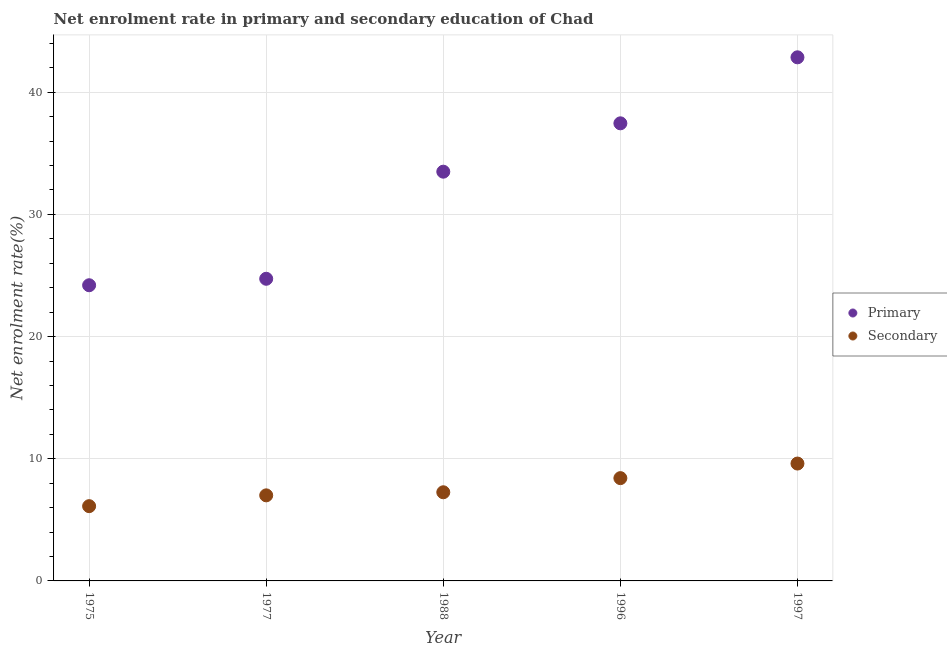How many different coloured dotlines are there?
Your answer should be compact. 2. What is the enrollment rate in primary education in 1988?
Provide a succinct answer. 33.5. Across all years, what is the maximum enrollment rate in primary education?
Keep it short and to the point. 42.86. Across all years, what is the minimum enrollment rate in primary education?
Your answer should be compact. 24.2. In which year was the enrollment rate in primary education maximum?
Provide a short and direct response. 1997. In which year was the enrollment rate in primary education minimum?
Offer a very short reply. 1975. What is the total enrollment rate in primary education in the graph?
Offer a terse response. 162.74. What is the difference between the enrollment rate in secondary education in 1975 and that in 1977?
Provide a succinct answer. -0.88. What is the difference between the enrollment rate in primary education in 1977 and the enrollment rate in secondary education in 1988?
Provide a short and direct response. 17.47. What is the average enrollment rate in secondary education per year?
Your answer should be very brief. 7.68. In the year 1996, what is the difference between the enrollment rate in primary education and enrollment rate in secondary education?
Make the answer very short. 29.04. What is the ratio of the enrollment rate in secondary education in 1975 to that in 1988?
Your answer should be compact. 0.84. Is the enrollment rate in primary education in 1975 less than that in 1997?
Provide a short and direct response. Yes. What is the difference between the highest and the second highest enrollment rate in primary education?
Give a very brief answer. 5.4. What is the difference between the highest and the lowest enrollment rate in primary education?
Your answer should be compact. 18.66. In how many years, is the enrollment rate in secondary education greater than the average enrollment rate in secondary education taken over all years?
Keep it short and to the point. 2. Is the sum of the enrollment rate in primary education in 1975 and 1996 greater than the maximum enrollment rate in secondary education across all years?
Keep it short and to the point. Yes. Does the enrollment rate in secondary education monotonically increase over the years?
Provide a succinct answer. Yes. Is the enrollment rate in secondary education strictly less than the enrollment rate in primary education over the years?
Provide a short and direct response. Yes. How many dotlines are there?
Offer a terse response. 2. How many legend labels are there?
Your answer should be compact. 2. What is the title of the graph?
Give a very brief answer. Net enrolment rate in primary and secondary education of Chad. Does "Mobile cellular" appear as one of the legend labels in the graph?
Make the answer very short. No. What is the label or title of the X-axis?
Your answer should be compact. Year. What is the label or title of the Y-axis?
Keep it short and to the point. Net enrolment rate(%). What is the Net enrolment rate(%) in Primary in 1975?
Keep it short and to the point. 24.2. What is the Net enrolment rate(%) in Secondary in 1975?
Your answer should be compact. 6.12. What is the Net enrolment rate(%) of Primary in 1977?
Give a very brief answer. 24.73. What is the Net enrolment rate(%) in Secondary in 1977?
Offer a very short reply. 7. What is the Net enrolment rate(%) of Primary in 1988?
Your answer should be very brief. 33.5. What is the Net enrolment rate(%) in Secondary in 1988?
Give a very brief answer. 7.26. What is the Net enrolment rate(%) of Primary in 1996?
Keep it short and to the point. 37.46. What is the Net enrolment rate(%) of Secondary in 1996?
Provide a succinct answer. 8.41. What is the Net enrolment rate(%) in Primary in 1997?
Your answer should be compact. 42.86. What is the Net enrolment rate(%) in Secondary in 1997?
Ensure brevity in your answer.  9.61. Across all years, what is the maximum Net enrolment rate(%) in Primary?
Your answer should be very brief. 42.86. Across all years, what is the maximum Net enrolment rate(%) of Secondary?
Your answer should be very brief. 9.61. Across all years, what is the minimum Net enrolment rate(%) in Primary?
Offer a very short reply. 24.2. Across all years, what is the minimum Net enrolment rate(%) of Secondary?
Offer a terse response. 6.12. What is the total Net enrolment rate(%) in Primary in the graph?
Give a very brief answer. 162.74. What is the total Net enrolment rate(%) of Secondary in the graph?
Make the answer very short. 38.4. What is the difference between the Net enrolment rate(%) of Primary in 1975 and that in 1977?
Keep it short and to the point. -0.53. What is the difference between the Net enrolment rate(%) of Secondary in 1975 and that in 1977?
Your answer should be compact. -0.88. What is the difference between the Net enrolment rate(%) of Primary in 1975 and that in 1988?
Your answer should be very brief. -9.3. What is the difference between the Net enrolment rate(%) of Secondary in 1975 and that in 1988?
Provide a succinct answer. -1.14. What is the difference between the Net enrolment rate(%) of Primary in 1975 and that in 1996?
Your answer should be very brief. -13.25. What is the difference between the Net enrolment rate(%) of Secondary in 1975 and that in 1996?
Ensure brevity in your answer.  -2.29. What is the difference between the Net enrolment rate(%) in Primary in 1975 and that in 1997?
Your answer should be compact. -18.66. What is the difference between the Net enrolment rate(%) of Secondary in 1975 and that in 1997?
Ensure brevity in your answer.  -3.49. What is the difference between the Net enrolment rate(%) in Primary in 1977 and that in 1988?
Offer a terse response. -8.77. What is the difference between the Net enrolment rate(%) of Secondary in 1977 and that in 1988?
Your response must be concise. -0.25. What is the difference between the Net enrolment rate(%) of Primary in 1977 and that in 1996?
Offer a terse response. -12.72. What is the difference between the Net enrolment rate(%) of Secondary in 1977 and that in 1996?
Your answer should be very brief. -1.41. What is the difference between the Net enrolment rate(%) in Primary in 1977 and that in 1997?
Offer a terse response. -18.13. What is the difference between the Net enrolment rate(%) of Secondary in 1977 and that in 1997?
Offer a very short reply. -2.6. What is the difference between the Net enrolment rate(%) of Primary in 1988 and that in 1996?
Ensure brevity in your answer.  -3.96. What is the difference between the Net enrolment rate(%) in Secondary in 1988 and that in 1996?
Ensure brevity in your answer.  -1.16. What is the difference between the Net enrolment rate(%) of Primary in 1988 and that in 1997?
Your response must be concise. -9.36. What is the difference between the Net enrolment rate(%) of Secondary in 1988 and that in 1997?
Your response must be concise. -2.35. What is the difference between the Net enrolment rate(%) in Primary in 1996 and that in 1997?
Your answer should be very brief. -5.4. What is the difference between the Net enrolment rate(%) of Secondary in 1996 and that in 1997?
Make the answer very short. -1.19. What is the difference between the Net enrolment rate(%) of Primary in 1975 and the Net enrolment rate(%) of Secondary in 1977?
Your answer should be very brief. 17.2. What is the difference between the Net enrolment rate(%) of Primary in 1975 and the Net enrolment rate(%) of Secondary in 1988?
Offer a terse response. 16.95. What is the difference between the Net enrolment rate(%) of Primary in 1975 and the Net enrolment rate(%) of Secondary in 1996?
Keep it short and to the point. 15.79. What is the difference between the Net enrolment rate(%) of Primary in 1975 and the Net enrolment rate(%) of Secondary in 1997?
Offer a terse response. 14.59. What is the difference between the Net enrolment rate(%) of Primary in 1977 and the Net enrolment rate(%) of Secondary in 1988?
Ensure brevity in your answer.  17.47. What is the difference between the Net enrolment rate(%) in Primary in 1977 and the Net enrolment rate(%) in Secondary in 1996?
Give a very brief answer. 16.32. What is the difference between the Net enrolment rate(%) of Primary in 1977 and the Net enrolment rate(%) of Secondary in 1997?
Ensure brevity in your answer.  15.12. What is the difference between the Net enrolment rate(%) of Primary in 1988 and the Net enrolment rate(%) of Secondary in 1996?
Offer a terse response. 25.08. What is the difference between the Net enrolment rate(%) of Primary in 1988 and the Net enrolment rate(%) of Secondary in 1997?
Ensure brevity in your answer.  23.89. What is the difference between the Net enrolment rate(%) in Primary in 1996 and the Net enrolment rate(%) in Secondary in 1997?
Ensure brevity in your answer.  27.85. What is the average Net enrolment rate(%) in Primary per year?
Ensure brevity in your answer.  32.55. What is the average Net enrolment rate(%) in Secondary per year?
Your answer should be very brief. 7.68. In the year 1975, what is the difference between the Net enrolment rate(%) in Primary and Net enrolment rate(%) in Secondary?
Provide a succinct answer. 18.08. In the year 1977, what is the difference between the Net enrolment rate(%) of Primary and Net enrolment rate(%) of Secondary?
Ensure brevity in your answer.  17.73. In the year 1988, what is the difference between the Net enrolment rate(%) in Primary and Net enrolment rate(%) in Secondary?
Give a very brief answer. 26.24. In the year 1996, what is the difference between the Net enrolment rate(%) in Primary and Net enrolment rate(%) in Secondary?
Make the answer very short. 29.04. In the year 1997, what is the difference between the Net enrolment rate(%) in Primary and Net enrolment rate(%) in Secondary?
Provide a short and direct response. 33.25. What is the ratio of the Net enrolment rate(%) in Primary in 1975 to that in 1977?
Give a very brief answer. 0.98. What is the ratio of the Net enrolment rate(%) in Secondary in 1975 to that in 1977?
Give a very brief answer. 0.87. What is the ratio of the Net enrolment rate(%) in Primary in 1975 to that in 1988?
Your answer should be very brief. 0.72. What is the ratio of the Net enrolment rate(%) in Secondary in 1975 to that in 1988?
Your response must be concise. 0.84. What is the ratio of the Net enrolment rate(%) in Primary in 1975 to that in 1996?
Offer a very short reply. 0.65. What is the ratio of the Net enrolment rate(%) of Secondary in 1975 to that in 1996?
Your answer should be compact. 0.73. What is the ratio of the Net enrolment rate(%) of Primary in 1975 to that in 1997?
Offer a very short reply. 0.56. What is the ratio of the Net enrolment rate(%) in Secondary in 1975 to that in 1997?
Offer a very short reply. 0.64. What is the ratio of the Net enrolment rate(%) in Primary in 1977 to that in 1988?
Your response must be concise. 0.74. What is the ratio of the Net enrolment rate(%) of Secondary in 1977 to that in 1988?
Ensure brevity in your answer.  0.97. What is the ratio of the Net enrolment rate(%) in Primary in 1977 to that in 1996?
Make the answer very short. 0.66. What is the ratio of the Net enrolment rate(%) in Secondary in 1977 to that in 1996?
Your response must be concise. 0.83. What is the ratio of the Net enrolment rate(%) of Primary in 1977 to that in 1997?
Make the answer very short. 0.58. What is the ratio of the Net enrolment rate(%) in Secondary in 1977 to that in 1997?
Offer a very short reply. 0.73. What is the ratio of the Net enrolment rate(%) in Primary in 1988 to that in 1996?
Your answer should be very brief. 0.89. What is the ratio of the Net enrolment rate(%) of Secondary in 1988 to that in 1996?
Provide a succinct answer. 0.86. What is the ratio of the Net enrolment rate(%) in Primary in 1988 to that in 1997?
Your response must be concise. 0.78. What is the ratio of the Net enrolment rate(%) of Secondary in 1988 to that in 1997?
Keep it short and to the point. 0.76. What is the ratio of the Net enrolment rate(%) of Primary in 1996 to that in 1997?
Make the answer very short. 0.87. What is the ratio of the Net enrolment rate(%) in Secondary in 1996 to that in 1997?
Your answer should be compact. 0.88. What is the difference between the highest and the second highest Net enrolment rate(%) in Primary?
Make the answer very short. 5.4. What is the difference between the highest and the second highest Net enrolment rate(%) of Secondary?
Make the answer very short. 1.19. What is the difference between the highest and the lowest Net enrolment rate(%) in Primary?
Offer a very short reply. 18.66. What is the difference between the highest and the lowest Net enrolment rate(%) of Secondary?
Your response must be concise. 3.49. 